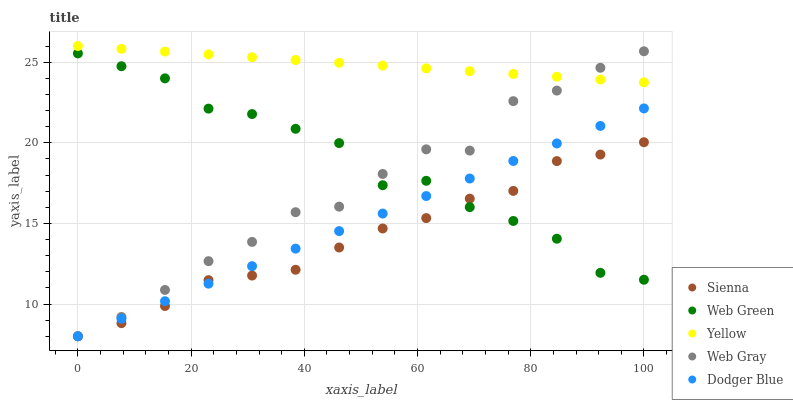Does Sienna have the minimum area under the curve?
Answer yes or no. Yes. Does Yellow have the maximum area under the curve?
Answer yes or no. Yes. Does Web Gray have the minimum area under the curve?
Answer yes or no. No. Does Web Gray have the maximum area under the curve?
Answer yes or no. No. Is Dodger Blue the smoothest?
Answer yes or no. Yes. Is Web Gray the roughest?
Answer yes or no. Yes. Is Web Gray the smoothest?
Answer yes or no. No. Is Dodger Blue the roughest?
Answer yes or no. No. Does Sienna have the lowest value?
Answer yes or no. Yes. Does Yellow have the lowest value?
Answer yes or no. No. Does Yellow have the highest value?
Answer yes or no. Yes. Does Web Gray have the highest value?
Answer yes or no. No. Is Web Green less than Yellow?
Answer yes or no. Yes. Is Yellow greater than Sienna?
Answer yes or no. Yes. Does Web Gray intersect Dodger Blue?
Answer yes or no. Yes. Is Web Gray less than Dodger Blue?
Answer yes or no. No. Is Web Gray greater than Dodger Blue?
Answer yes or no. No. Does Web Green intersect Yellow?
Answer yes or no. No. 